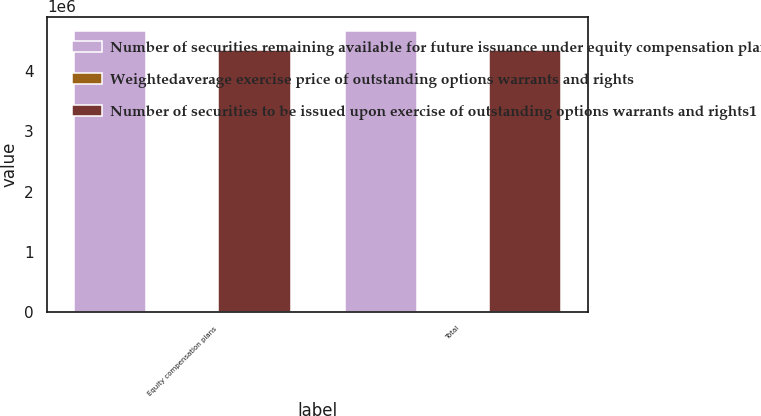Convert chart. <chart><loc_0><loc_0><loc_500><loc_500><stacked_bar_chart><ecel><fcel>Equity compensation plans<fcel>Total<nl><fcel>Number of securities remaining available for future issuance under equity compensation plans excluding securities reflected in column2<fcel>4.67314e+06<fcel>4.67314e+06<nl><fcel>Weightedaverage exercise price of outstanding options warrants and rights<fcel>31.74<fcel>31.74<nl><fcel>Number of securities to be issued upon exercise of outstanding options warrants and rights1<fcel>4.35365e+06<fcel>4.35365e+06<nl></chart> 